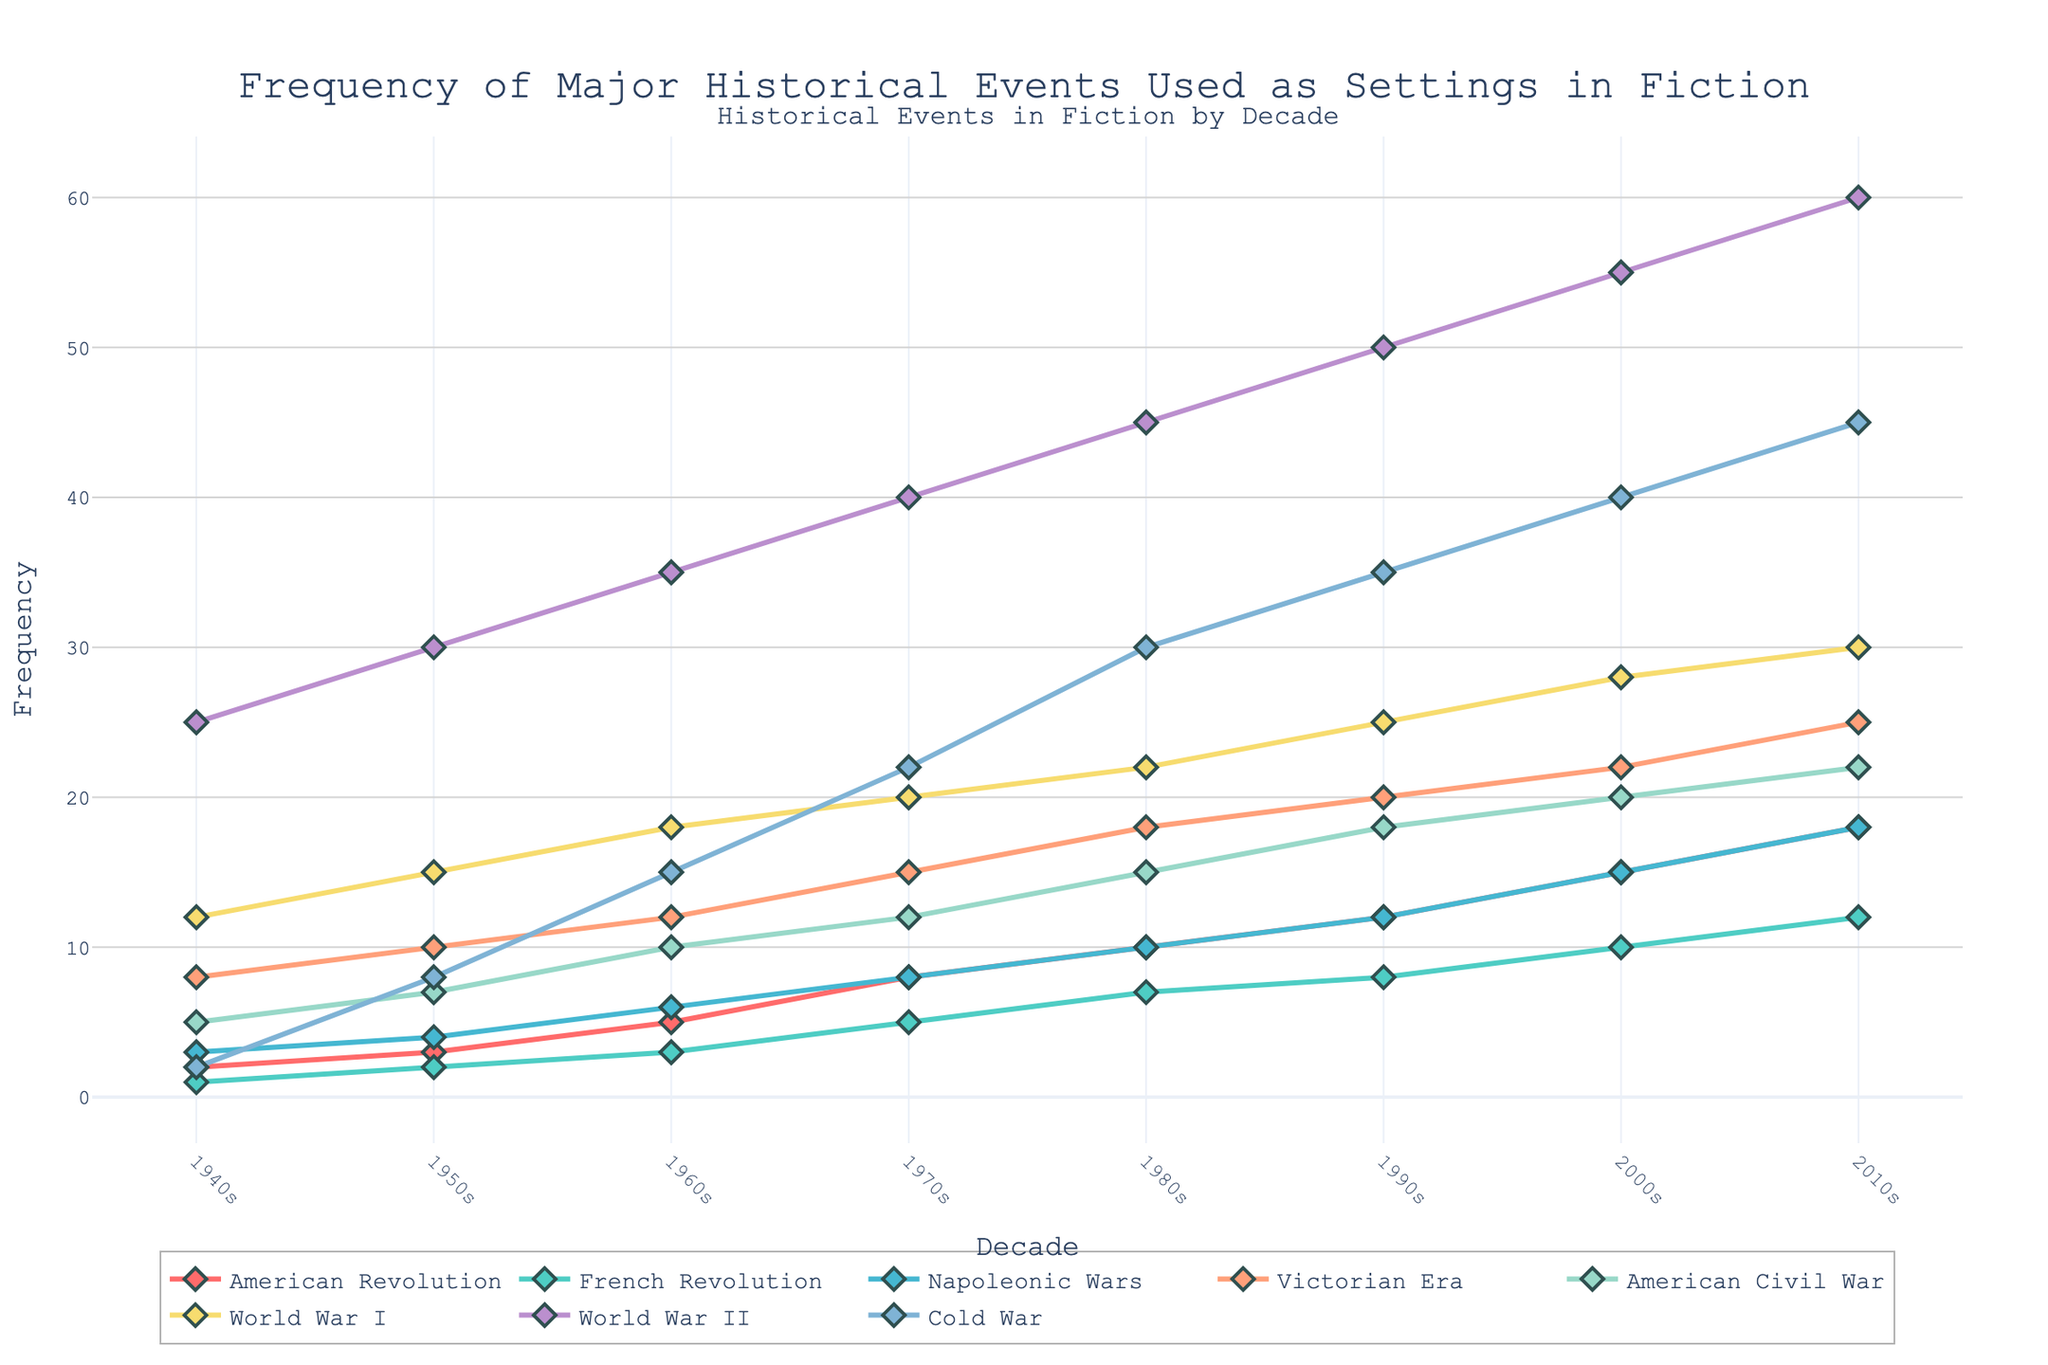what historical event has the highest frequency in the 1940s? In the 1940s, compare the frequencies of all historical events. The event with the highest frequency is World War II, at 25.
Answer: World War II Between which two decades did the frequency of the Victorian Era increase the most? Compare the frequency differences of the Victorian Era between consecutive decades. The biggest increase occurred between the 1940s and 1950s, where it increased by 2 (from 8 to 10).
Answer: 1940s and 1950s Which event had a lower frequency in the 1980s compared to the 2000s? Review the frequencies of each event in the 1980s and the 2000s. Events that increased include: American Revolution (10 to 15), French Revolution (7 to 10), Napoleonic Wars (10 to 15), Victorian Era (18 to 22), American Civil War (15 to 20), World War I (22 to 28), World War II (45 to 55), Cold War (30 to 40). All these increased, implying they had lower frequencies in the 1980s compared to the 2000s.
Answer: All listed events What's the difference in frequency of World War II between the 1950s and 2010s? Subtract the frequency of World War II in the 1950s (30) from its frequency in the 2010s (60). The calculation is 60 - 30 = 30.
Answer: 30 Which historical event shows a steady increase in frequency throughout all decades? Examine each historical event trend line, and check if each increment is positive from the 1940s to the 2010s. The Cold War is the event that consistently increases across all decades.
Answer: Cold War What is the average frequency of the American Civil War across all decades shown? Sum the frequencies of the American Civil War across all decades (5 + 7 + 10 + 12 + 15 + 18 + 20 + 22) and divide by the number of decades (8). The calculation is (5 + 7 + 10 + 12 + 15 + 18 + 20 + 22) / 8 = 13.625.
Answer: 13.625 In what decade did the Cold War see the biggest increase in frequency, and by how much? Review the frequency differences of the Cold War between consecutive decades. The largest increase occurred between the 1940s and 1950s, where it increased by 8 (from 2 to 10).
Answer: 1940s to 1950s, by 6 Identify a historical event that did not experience any frequency decrease across the decades. By examining the trend lines, all events show increasing trends, with none showing a decrease in any decade.
Answer: All listed events 